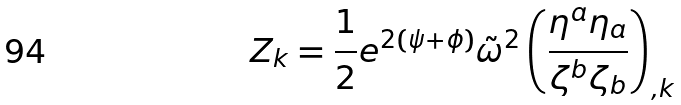Convert formula to latex. <formula><loc_0><loc_0><loc_500><loc_500>Z _ { k } = \frac { 1 } { 2 } e ^ { 2 ( \psi + \phi ) } \tilde { \omega } ^ { 2 } \left ( \frac { \eta ^ { a } \eta _ { a } } { \zeta ^ { b } \zeta _ { b } } \right ) _ { , k }</formula> 